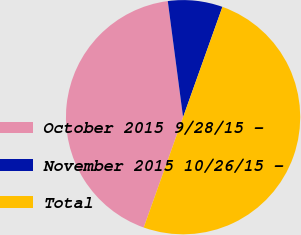Convert chart. <chart><loc_0><loc_0><loc_500><loc_500><pie_chart><fcel>October 2015 9/28/15 -<fcel>November 2015 10/26/15 -<fcel>Total<nl><fcel>42.46%<fcel>7.54%<fcel>50.0%<nl></chart> 